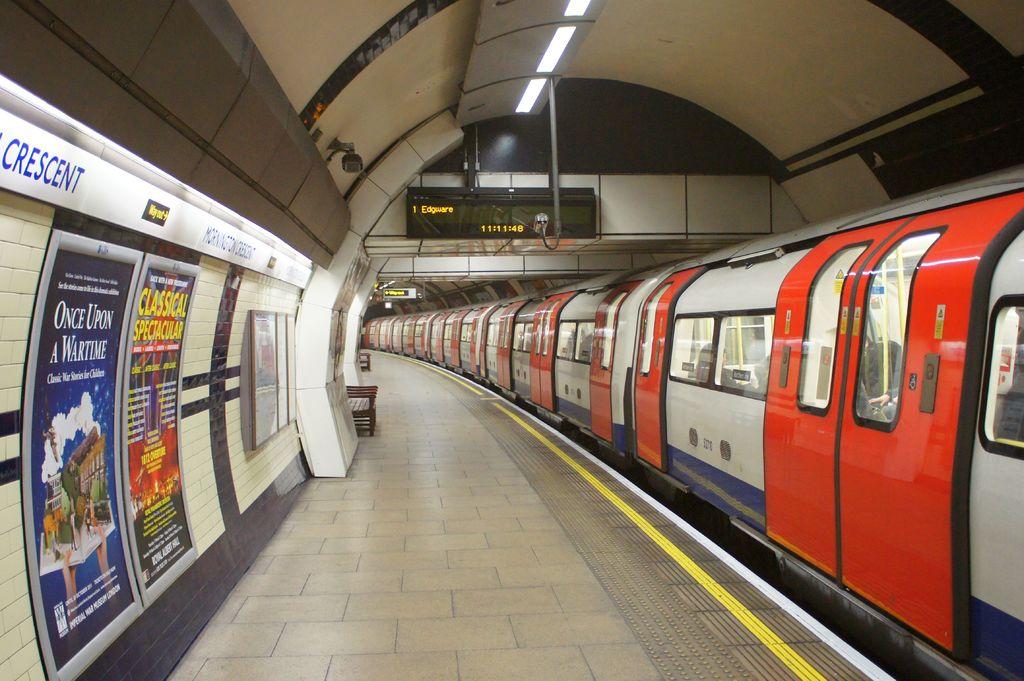What is the time on the megatron?
Your answer should be very brief. 11:11:48. 